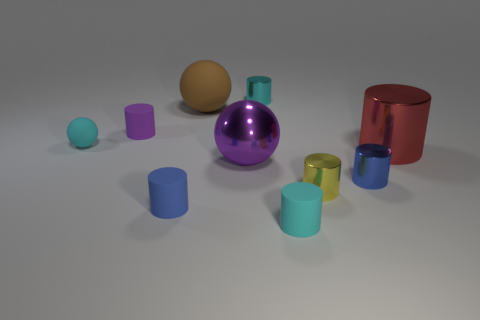Subtract all purple rubber cylinders. How many cylinders are left? 6 Subtract all blue cylinders. How many cylinders are left? 5 Subtract 2 cylinders. How many cylinders are left? 5 Subtract all green cylinders. Subtract all blue blocks. How many cylinders are left? 7 Subtract all balls. How many objects are left? 7 Subtract 0 gray cubes. How many objects are left? 10 Subtract all brown metal things. Subtract all cyan objects. How many objects are left? 7 Add 8 tiny blue cylinders. How many tiny blue cylinders are left? 10 Add 9 large purple metallic objects. How many large purple metallic objects exist? 10 